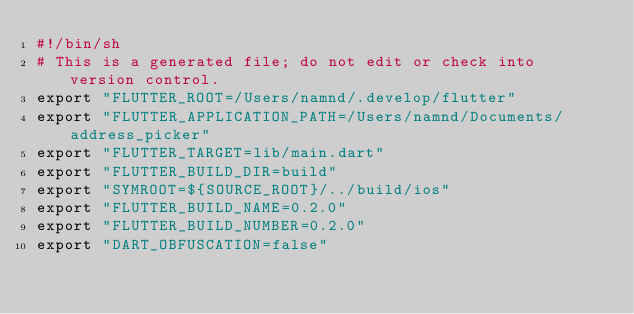Convert code to text. <code><loc_0><loc_0><loc_500><loc_500><_Bash_>#!/bin/sh
# This is a generated file; do not edit or check into version control.
export "FLUTTER_ROOT=/Users/namnd/.develop/flutter"
export "FLUTTER_APPLICATION_PATH=/Users/namnd/Documents/address_picker"
export "FLUTTER_TARGET=lib/main.dart"
export "FLUTTER_BUILD_DIR=build"
export "SYMROOT=${SOURCE_ROOT}/../build/ios"
export "FLUTTER_BUILD_NAME=0.2.0"
export "FLUTTER_BUILD_NUMBER=0.2.0"
export "DART_OBFUSCATION=false"</code> 